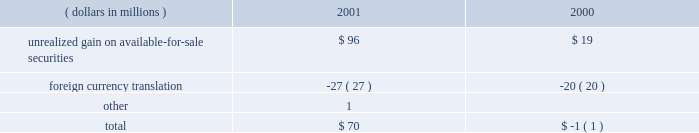A black-scholes option-pricing model was used for purposes of estimating the fair value of state street 2019s employee stock options at the grant date .
The following were the weighted average assumptions for the years ended december 31 , 2001 , 2000 and 1999 , respectively : risk-free interest rates of 3.99% ( 3.99 % ) , 5.75% ( 5.75 % ) and 5.90% ( 5.90 % ) ; dividend yields of 1.08% ( 1.08 % ) , .73% ( .73 % ) and .92% ( .92 % ) ; and volatility factors of the expected market price of state street common stock of .30 , .30 and .30 .
The estimated weighted average life of the stock options granted was 4.1 years for the years ended december 31 , 2001 , 2000 and 1999 .
O t h e r u n r e a l i z e d c o m p r e h e n s i v e i n c o m e ( l o s s ) at december 31 , the components of other unrealized comprehensive income ( loss ) , net of related taxes , were as follows: .
Note j shareholders 2019 rights plan in 1988 , state street declared a dividend of one preferred share purchase right for each outstanding share of common stock .
In 1998 , the rights agreement was amended and restated , and in 2001 , the rights plan was impacted by the 2-for-1 stock split .
Accordingly , a right may be exercised , under certain conditions , to purchase one eight-hundredths share of a series of participating preferred stock at an exercise price of $ 132.50 , subject to adjustment .
The rights become exercisable if a party acquires or obtains the right to acquire 10% ( 10 % ) or more of state street 2019s common stock or after commencement or public announcement of an offer for 10% ( 10 % ) or more of state street 2019s common stock .
When exercisable , under certain conditions , each right entitles the holder thereof to purchase shares of common stock , of either state street or of the acquirer , having a market value of two times the then-current exercise price of that right .
The rights expire in september 2008 , and may be redeemed at a price of $ .00125 per right , subject to adjustment , at any time prior to expiration or the acquisition of 10% ( 10 % ) of state street 2019s common stock .
Under certain circumstances , the rights may be redeemed after they become exercisable and may be subject to automatic redemption .
Note k regulatory matters r e g u l a t o r y c a p i t a l state street is subject to various regulatory capital requirements administered by federal banking agencies .
Failure to meet minimum capital requirements can initiate certain mandatory and discretionary actions by regulators that , if undertaken , could have a direct material effect on state street 2019s financial condition .
Under capital adequacy guidelines , state street must meet specific capital guidelines that involve quantitative measures of state street 2019s assets , liabilities and off-balance sheet items as calculated under regulatory accounting practices .
State street 2019s capital amounts and classification are subject to qualitative judgments by the regulators about components , risk weightings and other factors .
42 state street corporation .
In 2001 , what percent of gains were lost in foreign currency translation? 
Computations: (27 / (96 + 1))
Answer: 0.27835. A black-scholes option-pricing model was used for purposes of estimating the fair value of state street 2019s employee stock options at the grant date .
The following were the weighted average assumptions for the years ended december 31 , 2001 , 2000 and 1999 , respectively : risk-free interest rates of 3.99% ( 3.99 % ) , 5.75% ( 5.75 % ) and 5.90% ( 5.90 % ) ; dividend yields of 1.08% ( 1.08 % ) , .73% ( .73 % ) and .92% ( .92 % ) ; and volatility factors of the expected market price of state street common stock of .30 , .30 and .30 .
The estimated weighted average life of the stock options granted was 4.1 years for the years ended december 31 , 2001 , 2000 and 1999 .
O t h e r u n r e a l i z e d c o m p r e h e n s i v e i n c o m e ( l o s s ) at december 31 , the components of other unrealized comprehensive income ( loss ) , net of related taxes , were as follows: .
Note j shareholders 2019 rights plan in 1988 , state street declared a dividend of one preferred share purchase right for each outstanding share of common stock .
In 1998 , the rights agreement was amended and restated , and in 2001 , the rights plan was impacted by the 2-for-1 stock split .
Accordingly , a right may be exercised , under certain conditions , to purchase one eight-hundredths share of a series of participating preferred stock at an exercise price of $ 132.50 , subject to adjustment .
The rights become exercisable if a party acquires or obtains the right to acquire 10% ( 10 % ) or more of state street 2019s common stock or after commencement or public announcement of an offer for 10% ( 10 % ) or more of state street 2019s common stock .
When exercisable , under certain conditions , each right entitles the holder thereof to purchase shares of common stock , of either state street or of the acquirer , having a market value of two times the then-current exercise price of that right .
The rights expire in september 2008 , and may be redeemed at a price of $ .00125 per right , subject to adjustment , at any time prior to expiration or the acquisition of 10% ( 10 % ) of state street 2019s common stock .
Under certain circumstances , the rights may be redeemed after they become exercisable and may be subject to automatic redemption .
Note k regulatory matters r e g u l a t o r y c a p i t a l state street is subject to various regulatory capital requirements administered by federal banking agencies .
Failure to meet minimum capital requirements can initiate certain mandatory and discretionary actions by regulators that , if undertaken , could have a direct material effect on state street 2019s financial condition .
Under capital adequacy guidelines , state street must meet specific capital guidelines that involve quantitative measures of state street 2019s assets , liabilities and off-balance sheet items as calculated under regulatory accounting practices .
State street 2019s capital amounts and classification are subject to qualitative judgments by the regulators about components , risk weightings and other factors .
42 state street corporation .
Between 2000 and 2001 , what was the percent increase of unrealized gains? 
Computations: ((96 - 19) / 19)
Answer: 4.05263. A black-scholes option-pricing model was used for purposes of estimating the fair value of state street 2019s employee stock options at the grant date .
The following were the weighted average assumptions for the years ended december 31 , 2001 , 2000 and 1999 , respectively : risk-free interest rates of 3.99% ( 3.99 % ) , 5.75% ( 5.75 % ) and 5.90% ( 5.90 % ) ; dividend yields of 1.08% ( 1.08 % ) , .73% ( .73 % ) and .92% ( .92 % ) ; and volatility factors of the expected market price of state street common stock of .30 , .30 and .30 .
The estimated weighted average life of the stock options granted was 4.1 years for the years ended december 31 , 2001 , 2000 and 1999 .
O t h e r u n r e a l i z e d c o m p r e h e n s i v e i n c o m e ( l o s s ) at december 31 , the components of other unrealized comprehensive income ( loss ) , net of related taxes , were as follows: .
Note j shareholders 2019 rights plan in 1988 , state street declared a dividend of one preferred share purchase right for each outstanding share of common stock .
In 1998 , the rights agreement was amended and restated , and in 2001 , the rights plan was impacted by the 2-for-1 stock split .
Accordingly , a right may be exercised , under certain conditions , to purchase one eight-hundredths share of a series of participating preferred stock at an exercise price of $ 132.50 , subject to adjustment .
The rights become exercisable if a party acquires or obtains the right to acquire 10% ( 10 % ) or more of state street 2019s common stock or after commencement or public announcement of an offer for 10% ( 10 % ) or more of state street 2019s common stock .
When exercisable , under certain conditions , each right entitles the holder thereof to purchase shares of common stock , of either state street or of the acquirer , having a market value of two times the then-current exercise price of that right .
The rights expire in september 2008 , and may be redeemed at a price of $ .00125 per right , subject to adjustment , at any time prior to expiration or the acquisition of 10% ( 10 % ) of state street 2019s common stock .
Under certain circumstances , the rights may be redeemed after they become exercisable and may be subject to automatic redemption .
Note k regulatory matters r e g u l a t o r y c a p i t a l state street is subject to various regulatory capital requirements administered by federal banking agencies .
Failure to meet minimum capital requirements can initiate certain mandatory and discretionary actions by regulators that , if undertaken , could have a direct material effect on state street 2019s financial condition .
Under capital adequacy guidelines , state street must meet specific capital guidelines that involve quantitative measures of state street 2019s assets , liabilities and off-balance sheet items as calculated under regulatory accounting practices .
State street 2019s capital amounts and classification are subject to qualitative judgments by the regulators about components , risk weightings and other factors .
42 state street corporation .
Assuming that the outstanding number of shares is 100 million before the 2001 stock split , how many shares will be outstanding after the split , in millions? 
Computations: (100 * 2)
Answer: 200.0. 